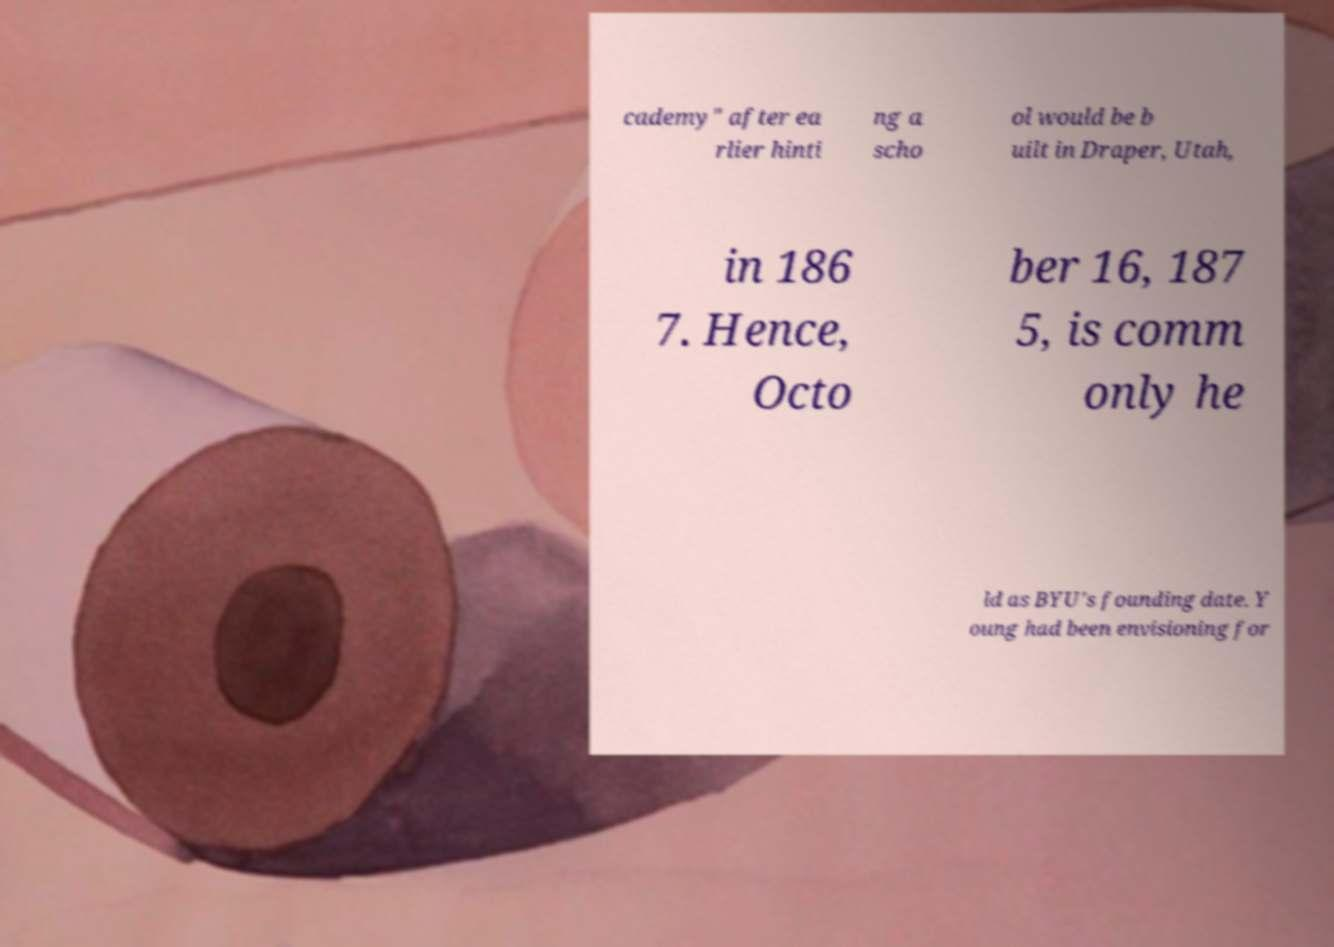Can you accurately transcribe the text from the provided image for me? cademy" after ea rlier hinti ng a scho ol would be b uilt in Draper, Utah, in 186 7. Hence, Octo ber 16, 187 5, is comm only he ld as BYU's founding date. Y oung had been envisioning for 